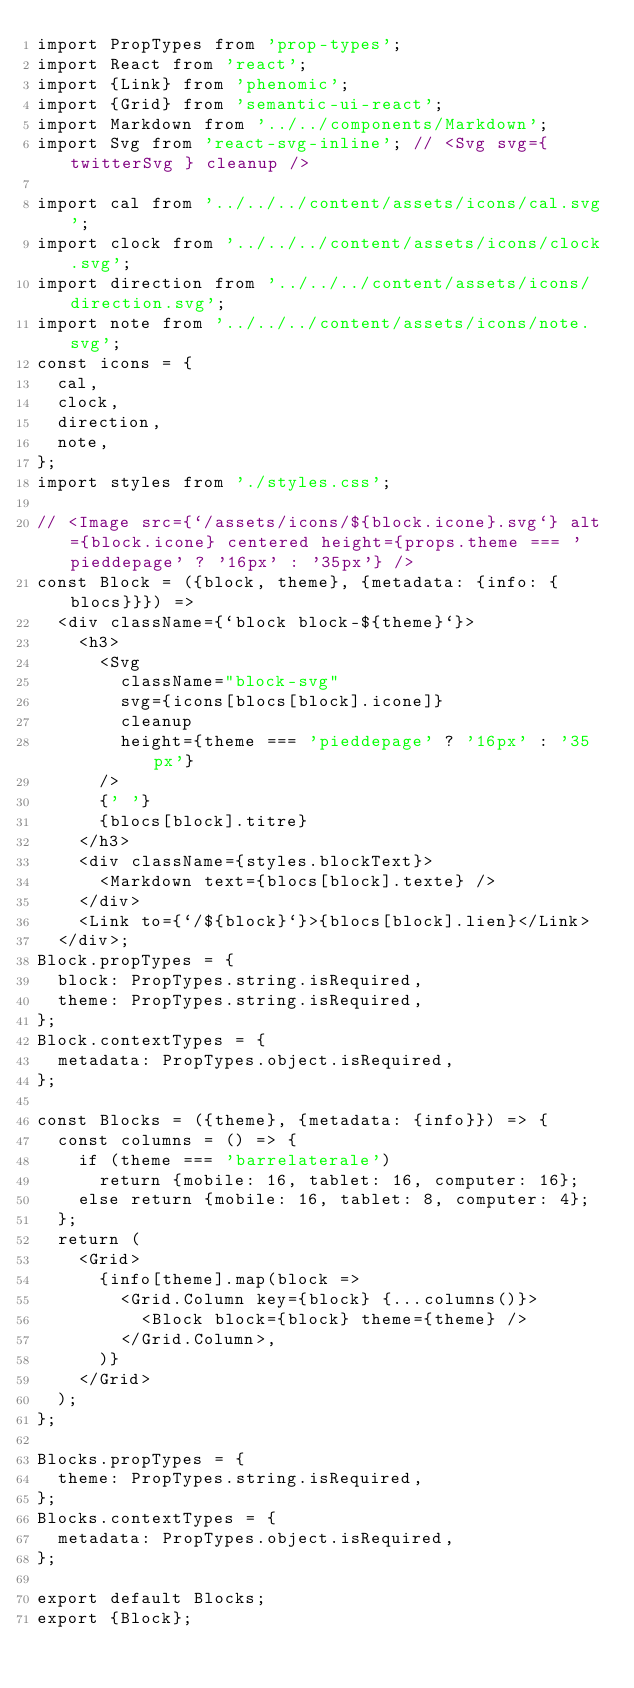Convert code to text. <code><loc_0><loc_0><loc_500><loc_500><_JavaScript_>import PropTypes from 'prop-types';
import React from 'react';
import {Link} from 'phenomic';
import {Grid} from 'semantic-ui-react';
import Markdown from '../../components/Markdown';
import Svg from 'react-svg-inline'; // <Svg svg={ twitterSvg } cleanup />

import cal from '../../../content/assets/icons/cal.svg';
import clock from '../../../content/assets/icons/clock.svg';
import direction from '../../../content/assets/icons/direction.svg';
import note from '../../../content/assets/icons/note.svg';
const icons = {
  cal,
  clock,
  direction,
  note,
};
import styles from './styles.css';

// <Image src={`/assets/icons/${block.icone}.svg`} alt={block.icone} centered height={props.theme === 'pieddepage' ? '16px' : '35px'} />
const Block = ({block, theme}, {metadata: {info: {blocs}}}) =>
  <div className={`block block-${theme}`}>
    <h3>
      <Svg
        className="block-svg"
        svg={icons[blocs[block].icone]}
        cleanup
        height={theme === 'pieddepage' ? '16px' : '35px'}
      />
      {' '}
      {blocs[block].titre}
    </h3>
    <div className={styles.blockText}>
      <Markdown text={blocs[block].texte} />
    </div>
    <Link to={`/${block}`}>{blocs[block].lien}</Link>
  </div>;
Block.propTypes = {
  block: PropTypes.string.isRequired,
  theme: PropTypes.string.isRequired,
};
Block.contextTypes = {
  metadata: PropTypes.object.isRequired,
};

const Blocks = ({theme}, {metadata: {info}}) => {
  const columns = () => {
    if (theme === 'barrelaterale')
      return {mobile: 16, tablet: 16, computer: 16};
    else return {mobile: 16, tablet: 8, computer: 4};
  };
  return (
    <Grid>
      {info[theme].map(block =>
        <Grid.Column key={block} {...columns()}>
          <Block block={block} theme={theme} />
        </Grid.Column>,
      )}
    </Grid>
  );
};

Blocks.propTypes = {
  theme: PropTypes.string.isRequired,
};
Blocks.contextTypes = {
  metadata: PropTypes.object.isRequired,
};

export default Blocks;
export {Block};
</code> 